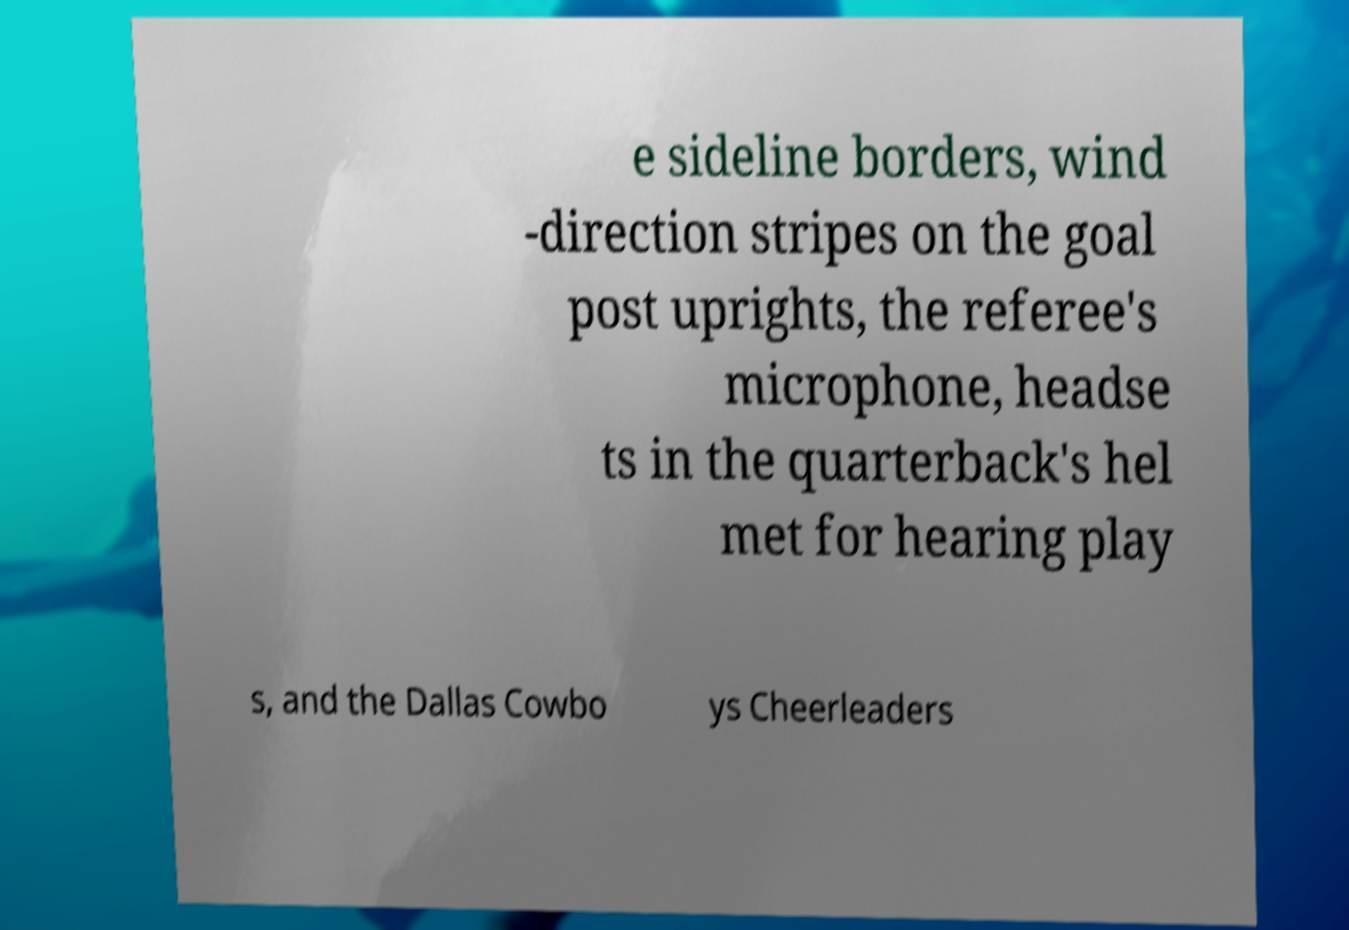There's text embedded in this image that I need extracted. Can you transcribe it verbatim? e sideline borders, wind -direction stripes on the goal post uprights, the referee's microphone, headse ts in the quarterback's hel met for hearing play s, and the Dallas Cowbo ys Cheerleaders 